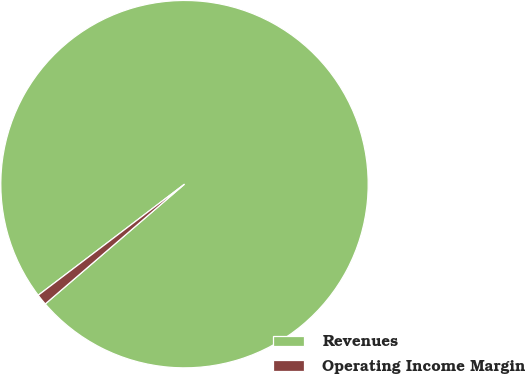Convert chart to OTSL. <chart><loc_0><loc_0><loc_500><loc_500><pie_chart><fcel>Revenues<fcel>Operating Income Margin<nl><fcel>99.03%<fcel>0.97%<nl></chart> 